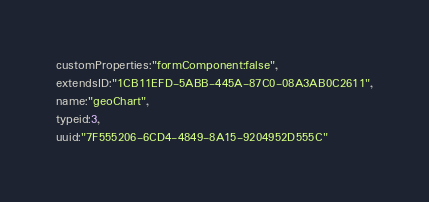<code> <loc_0><loc_0><loc_500><loc_500><_VisualBasic_>customProperties:"formComponent:false",
extendsID:"1CB11EFD-5ABB-445A-87C0-08A3AB0C2611",
name:"geoChart",
typeid:3,
uuid:"7F555206-6CD4-4849-8A15-9204952D555C"</code> 